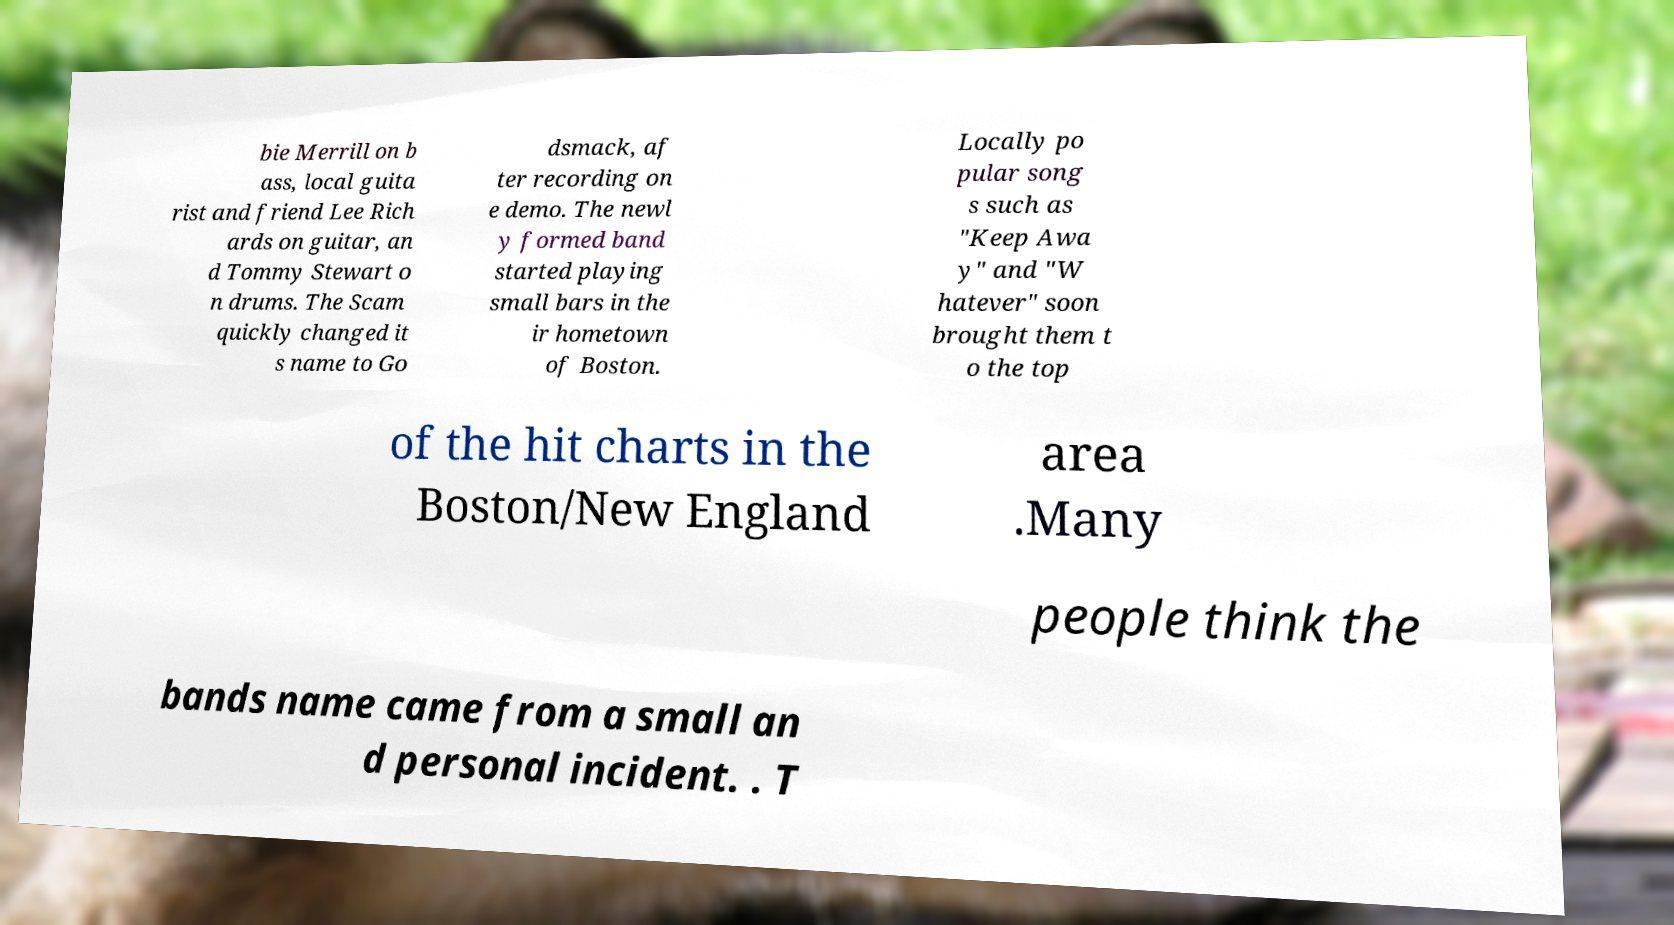Could you assist in decoding the text presented in this image and type it out clearly? bie Merrill on b ass, local guita rist and friend Lee Rich ards on guitar, an d Tommy Stewart o n drums. The Scam quickly changed it s name to Go dsmack, af ter recording on e demo. The newl y formed band started playing small bars in the ir hometown of Boston. Locally po pular song s such as "Keep Awa y" and "W hatever" soon brought them t o the top of the hit charts in the Boston/New England area .Many people think the bands name came from a small an d personal incident. . T 